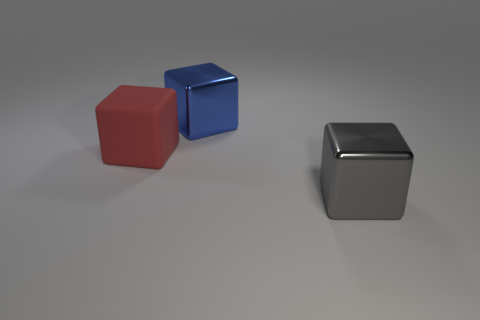Add 2 blue things. How many objects exist? 5 Subtract all matte blocks. Subtract all big gray blocks. How many objects are left? 1 Add 1 red matte objects. How many red matte objects are left? 2 Add 1 big gray things. How many big gray things exist? 2 Subtract 0 brown spheres. How many objects are left? 3 